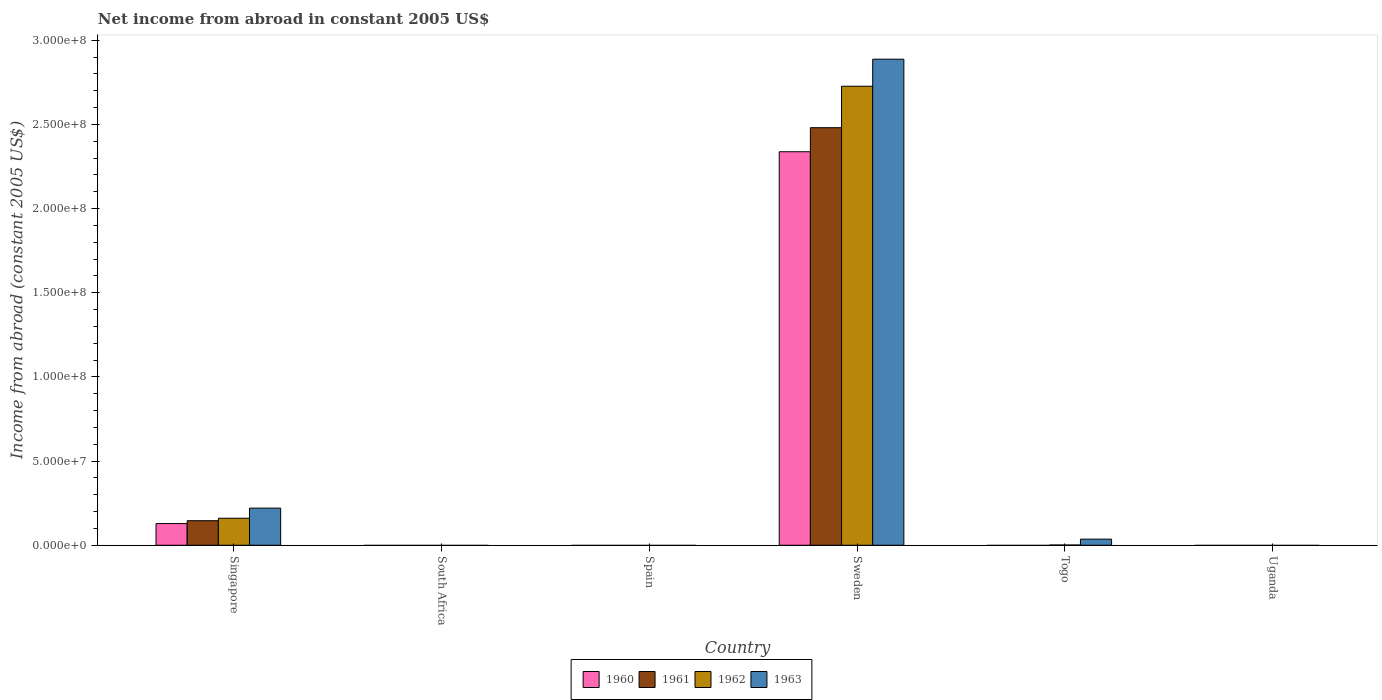How many different coloured bars are there?
Your response must be concise. 4. How many bars are there on the 2nd tick from the left?
Offer a terse response. 0. How many bars are there on the 4th tick from the right?
Your response must be concise. 0. What is the label of the 2nd group of bars from the left?
Your answer should be very brief. South Africa. In how many cases, is the number of bars for a given country not equal to the number of legend labels?
Give a very brief answer. 4. What is the net income from abroad in 1961 in Sweden?
Offer a terse response. 2.48e+08. Across all countries, what is the maximum net income from abroad in 1960?
Make the answer very short. 2.34e+08. What is the total net income from abroad in 1962 in the graph?
Make the answer very short. 2.89e+08. What is the difference between the net income from abroad in 1960 in South Africa and the net income from abroad in 1961 in Spain?
Provide a short and direct response. 0. What is the average net income from abroad in 1961 per country?
Ensure brevity in your answer.  4.38e+07. What is the difference between the net income from abroad of/in 1962 and net income from abroad of/in 1963 in Singapore?
Keep it short and to the point. -6.01e+06. What is the ratio of the net income from abroad in 1963 in Singapore to that in Sweden?
Your answer should be compact. 0.08. Is the net income from abroad in 1962 in Singapore less than that in Sweden?
Give a very brief answer. Yes. What is the difference between the highest and the second highest net income from abroad in 1962?
Your response must be concise. 2.57e+08. What is the difference between the highest and the lowest net income from abroad in 1962?
Provide a succinct answer. 2.73e+08. Is the sum of the net income from abroad in 1963 in Sweden and Togo greater than the maximum net income from abroad in 1960 across all countries?
Give a very brief answer. Yes. Is it the case that in every country, the sum of the net income from abroad in 1960 and net income from abroad in 1962 is greater than the net income from abroad in 1961?
Provide a short and direct response. No. How many bars are there?
Provide a short and direct response. 10. Are all the bars in the graph horizontal?
Your response must be concise. No. How many countries are there in the graph?
Keep it short and to the point. 6. Are the values on the major ticks of Y-axis written in scientific E-notation?
Offer a very short reply. Yes. Does the graph contain grids?
Make the answer very short. No. Where does the legend appear in the graph?
Make the answer very short. Bottom center. What is the title of the graph?
Your response must be concise. Net income from abroad in constant 2005 US$. Does "1963" appear as one of the legend labels in the graph?
Offer a terse response. Yes. What is the label or title of the X-axis?
Your response must be concise. Country. What is the label or title of the Y-axis?
Your answer should be very brief. Income from abroad (constant 2005 US$). What is the Income from abroad (constant 2005 US$) in 1960 in Singapore?
Provide a succinct answer. 1.29e+07. What is the Income from abroad (constant 2005 US$) of 1961 in Singapore?
Provide a succinct answer. 1.46e+07. What is the Income from abroad (constant 2005 US$) in 1962 in Singapore?
Keep it short and to the point. 1.60e+07. What is the Income from abroad (constant 2005 US$) in 1963 in Singapore?
Your answer should be compact. 2.20e+07. What is the Income from abroad (constant 2005 US$) of 1960 in South Africa?
Your answer should be compact. 0. What is the Income from abroad (constant 2005 US$) in 1961 in South Africa?
Keep it short and to the point. 0. What is the Income from abroad (constant 2005 US$) of 1960 in Sweden?
Provide a short and direct response. 2.34e+08. What is the Income from abroad (constant 2005 US$) of 1961 in Sweden?
Ensure brevity in your answer.  2.48e+08. What is the Income from abroad (constant 2005 US$) in 1962 in Sweden?
Provide a short and direct response. 2.73e+08. What is the Income from abroad (constant 2005 US$) in 1963 in Sweden?
Keep it short and to the point. 2.89e+08. What is the Income from abroad (constant 2005 US$) of 1962 in Togo?
Provide a short and direct response. 1.22e+05. What is the Income from abroad (constant 2005 US$) of 1963 in Togo?
Offer a very short reply. 3.62e+06. What is the Income from abroad (constant 2005 US$) in 1961 in Uganda?
Give a very brief answer. 0. What is the Income from abroad (constant 2005 US$) in 1962 in Uganda?
Offer a terse response. 0. What is the Income from abroad (constant 2005 US$) of 1963 in Uganda?
Provide a short and direct response. 0. Across all countries, what is the maximum Income from abroad (constant 2005 US$) of 1960?
Provide a succinct answer. 2.34e+08. Across all countries, what is the maximum Income from abroad (constant 2005 US$) of 1961?
Offer a terse response. 2.48e+08. Across all countries, what is the maximum Income from abroad (constant 2005 US$) of 1962?
Provide a short and direct response. 2.73e+08. Across all countries, what is the maximum Income from abroad (constant 2005 US$) in 1963?
Your response must be concise. 2.89e+08. Across all countries, what is the minimum Income from abroad (constant 2005 US$) of 1961?
Offer a terse response. 0. What is the total Income from abroad (constant 2005 US$) in 1960 in the graph?
Keep it short and to the point. 2.47e+08. What is the total Income from abroad (constant 2005 US$) in 1961 in the graph?
Give a very brief answer. 2.63e+08. What is the total Income from abroad (constant 2005 US$) in 1962 in the graph?
Provide a short and direct response. 2.89e+08. What is the total Income from abroad (constant 2005 US$) of 1963 in the graph?
Offer a very short reply. 3.14e+08. What is the difference between the Income from abroad (constant 2005 US$) in 1960 in Singapore and that in Sweden?
Make the answer very short. -2.21e+08. What is the difference between the Income from abroad (constant 2005 US$) of 1961 in Singapore and that in Sweden?
Offer a very short reply. -2.34e+08. What is the difference between the Income from abroad (constant 2005 US$) of 1962 in Singapore and that in Sweden?
Provide a short and direct response. -2.57e+08. What is the difference between the Income from abroad (constant 2005 US$) of 1963 in Singapore and that in Sweden?
Your answer should be compact. -2.67e+08. What is the difference between the Income from abroad (constant 2005 US$) in 1962 in Singapore and that in Togo?
Offer a terse response. 1.59e+07. What is the difference between the Income from abroad (constant 2005 US$) of 1963 in Singapore and that in Togo?
Keep it short and to the point. 1.84e+07. What is the difference between the Income from abroad (constant 2005 US$) of 1962 in Sweden and that in Togo?
Offer a very short reply. 2.73e+08. What is the difference between the Income from abroad (constant 2005 US$) in 1963 in Sweden and that in Togo?
Give a very brief answer. 2.85e+08. What is the difference between the Income from abroad (constant 2005 US$) in 1960 in Singapore and the Income from abroad (constant 2005 US$) in 1961 in Sweden?
Your response must be concise. -2.35e+08. What is the difference between the Income from abroad (constant 2005 US$) of 1960 in Singapore and the Income from abroad (constant 2005 US$) of 1962 in Sweden?
Your response must be concise. -2.60e+08. What is the difference between the Income from abroad (constant 2005 US$) of 1960 in Singapore and the Income from abroad (constant 2005 US$) of 1963 in Sweden?
Keep it short and to the point. -2.76e+08. What is the difference between the Income from abroad (constant 2005 US$) of 1961 in Singapore and the Income from abroad (constant 2005 US$) of 1962 in Sweden?
Your response must be concise. -2.58e+08. What is the difference between the Income from abroad (constant 2005 US$) in 1961 in Singapore and the Income from abroad (constant 2005 US$) in 1963 in Sweden?
Make the answer very short. -2.74e+08. What is the difference between the Income from abroad (constant 2005 US$) in 1962 in Singapore and the Income from abroad (constant 2005 US$) in 1963 in Sweden?
Offer a very short reply. -2.73e+08. What is the difference between the Income from abroad (constant 2005 US$) of 1960 in Singapore and the Income from abroad (constant 2005 US$) of 1962 in Togo?
Make the answer very short. 1.27e+07. What is the difference between the Income from abroad (constant 2005 US$) in 1960 in Singapore and the Income from abroad (constant 2005 US$) in 1963 in Togo?
Provide a succinct answer. 9.25e+06. What is the difference between the Income from abroad (constant 2005 US$) of 1961 in Singapore and the Income from abroad (constant 2005 US$) of 1962 in Togo?
Ensure brevity in your answer.  1.44e+07. What is the difference between the Income from abroad (constant 2005 US$) of 1961 in Singapore and the Income from abroad (constant 2005 US$) of 1963 in Togo?
Offer a very short reply. 1.09e+07. What is the difference between the Income from abroad (constant 2005 US$) in 1962 in Singapore and the Income from abroad (constant 2005 US$) in 1963 in Togo?
Offer a terse response. 1.24e+07. What is the difference between the Income from abroad (constant 2005 US$) in 1960 in Sweden and the Income from abroad (constant 2005 US$) in 1962 in Togo?
Your response must be concise. 2.34e+08. What is the difference between the Income from abroad (constant 2005 US$) of 1960 in Sweden and the Income from abroad (constant 2005 US$) of 1963 in Togo?
Keep it short and to the point. 2.30e+08. What is the difference between the Income from abroad (constant 2005 US$) in 1961 in Sweden and the Income from abroad (constant 2005 US$) in 1962 in Togo?
Keep it short and to the point. 2.48e+08. What is the difference between the Income from abroad (constant 2005 US$) in 1961 in Sweden and the Income from abroad (constant 2005 US$) in 1963 in Togo?
Offer a very short reply. 2.44e+08. What is the difference between the Income from abroad (constant 2005 US$) of 1962 in Sweden and the Income from abroad (constant 2005 US$) of 1963 in Togo?
Your answer should be compact. 2.69e+08. What is the average Income from abroad (constant 2005 US$) in 1960 per country?
Give a very brief answer. 4.11e+07. What is the average Income from abroad (constant 2005 US$) in 1961 per country?
Provide a succinct answer. 4.38e+07. What is the average Income from abroad (constant 2005 US$) in 1962 per country?
Your answer should be very brief. 4.81e+07. What is the average Income from abroad (constant 2005 US$) in 1963 per country?
Your answer should be compact. 5.24e+07. What is the difference between the Income from abroad (constant 2005 US$) in 1960 and Income from abroad (constant 2005 US$) in 1961 in Singapore?
Offer a very short reply. -1.70e+06. What is the difference between the Income from abroad (constant 2005 US$) of 1960 and Income from abroad (constant 2005 US$) of 1962 in Singapore?
Your response must be concise. -3.17e+06. What is the difference between the Income from abroad (constant 2005 US$) of 1960 and Income from abroad (constant 2005 US$) of 1963 in Singapore?
Offer a very short reply. -9.18e+06. What is the difference between the Income from abroad (constant 2005 US$) in 1961 and Income from abroad (constant 2005 US$) in 1962 in Singapore?
Your answer should be very brief. -1.47e+06. What is the difference between the Income from abroad (constant 2005 US$) in 1961 and Income from abroad (constant 2005 US$) in 1963 in Singapore?
Offer a very short reply. -7.48e+06. What is the difference between the Income from abroad (constant 2005 US$) of 1962 and Income from abroad (constant 2005 US$) of 1963 in Singapore?
Your answer should be compact. -6.01e+06. What is the difference between the Income from abroad (constant 2005 US$) of 1960 and Income from abroad (constant 2005 US$) of 1961 in Sweden?
Provide a short and direct response. -1.43e+07. What is the difference between the Income from abroad (constant 2005 US$) in 1960 and Income from abroad (constant 2005 US$) in 1962 in Sweden?
Ensure brevity in your answer.  -3.89e+07. What is the difference between the Income from abroad (constant 2005 US$) of 1960 and Income from abroad (constant 2005 US$) of 1963 in Sweden?
Give a very brief answer. -5.50e+07. What is the difference between the Income from abroad (constant 2005 US$) in 1961 and Income from abroad (constant 2005 US$) in 1962 in Sweden?
Keep it short and to the point. -2.46e+07. What is the difference between the Income from abroad (constant 2005 US$) of 1961 and Income from abroad (constant 2005 US$) of 1963 in Sweden?
Provide a short and direct response. -4.07e+07. What is the difference between the Income from abroad (constant 2005 US$) in 1962 and Income from abroad (constant 2005 US$) in 1963 in Sweden?
Give a very brief answer. -1.61e+07. What is the difference between the Income from abroad (constant 2005 US$) in 1962 and Income from abroad (constant 2005 US$) in 1963 in Togo?
Keep it short and to the point. -3.50e+06. What is the ratio of the Income from abroad (constant 2005 US$) in 1960 in Singapore to that in Sweden?
Offer a very short reply. 0.06. What is the ratio of the Income from abroad (constant 2005 US$) in 1961 in Singapore to that in Sweden?
Your answer should be compact. 0.06. What is the ratio of the Income from abroad (constant 2005 US$) in 1962 in Singapore to that in Sweden?
Provide a succinct answer. 0.06. What is the ratio of the Income from abroad (constant 2005 US$) of 1963 in Singapore to that in Sweden?
Your answer should be compact. 0.08. What is the ratio of the Income from abroad (constant 2005 US$) in 1962 in Singapore to that in Togo?
Give a very brief answer. 131.21. What is the ratio of the Income from abroad (constant 2005 US$) in 1963 in Singapore to that in Togo?
Your response must be concise. 6.08. What is the ratio of the Income from abroad (constant 2005 US$) of 1962 in Sweden to that in Togo?
Offer a very short reply. 2230.99. What is the ratio of the Income from abroad (constant 2005 US$) in 1963 in Sweden to that in Togo?
Provide a succinct answer. 79.67. What is the difference between the highest and the second highest Income from abroad (constant 2005 US$) of 1962?
Offer a very short reply. 2.57e+08. What is the difference between the highest and the second highest Income from abroad (constant 2005 US$) in 1963?
Give a very brief answer. 2.67e+08. What is the difference between the highest and the lowest Income from abroad (constant 2005 US$) of 1960?
Offer a very short reply. 2.34e+08. What is the difference between the highest and the lowest Income from abroad (constant 2005 US$) of 1961?
Keep it short and to the point. 2.48e+08. What is the difference between the highest and the lowest Income from abroad (constant 2005 US$) in 1962?
Keep it short and to the point. 2.73e+08. What is the difference between the highest and the lowest Income from abroad (constant 2005 US$) of 1963?
Give a very brief answer. 2.89e+08. 